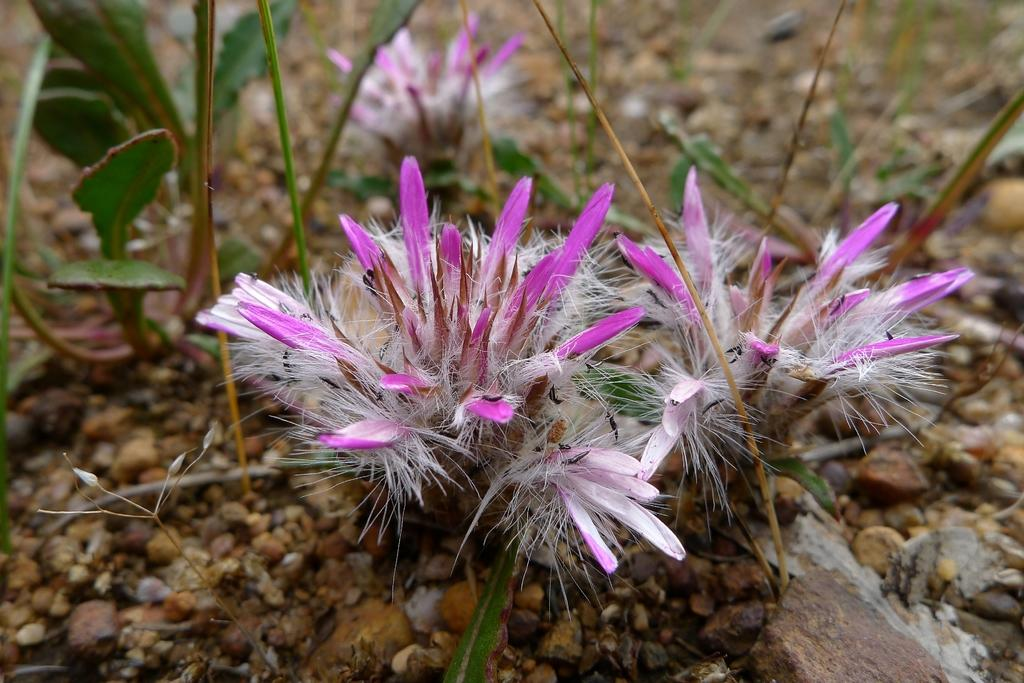What is located at the bottom of the image? There are stones at the bottom of the image. What can be seen in the middle of the image? There are plants and flowers in the middle of the image. How many apples are present in the image? There is no mention of apples in the image, so we cannot determine their presence or quantity. What type of babies can be seen playing with the stones in the image? There are no babies present in the image; it only features stones, plants, and flowers. 